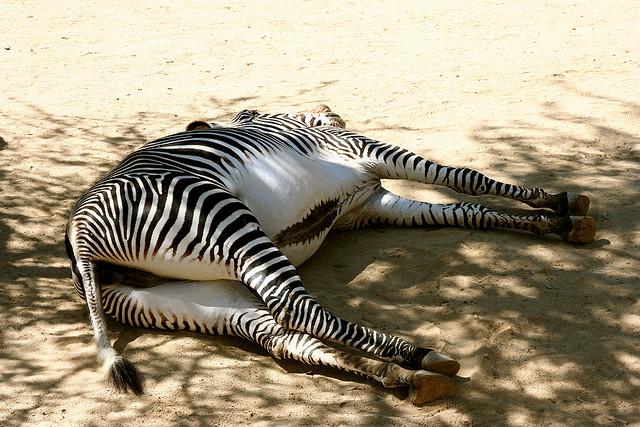Where could this be?
Keep it brief. Zoo. Is the zebra lying on grass?
Write a very short answer. No. What does the zebra have on his belly?
Answer briefly. Stripe. 